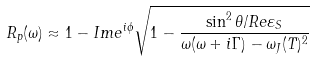Convert formula to latex. <formula><loc_0><loc_0><loc_500><loc_500>R _ { p } ( \omega ) \approx 1 - I m e ^ { i \phi } \sqrt { 1 - \frac { \sin ^ { 2 } \theta / R e \varepsilon _ { S } } { \omega ( \omega + i \Gamma ) - \omega _ { J } ( T ) ^ { 2 } } }</formula> 